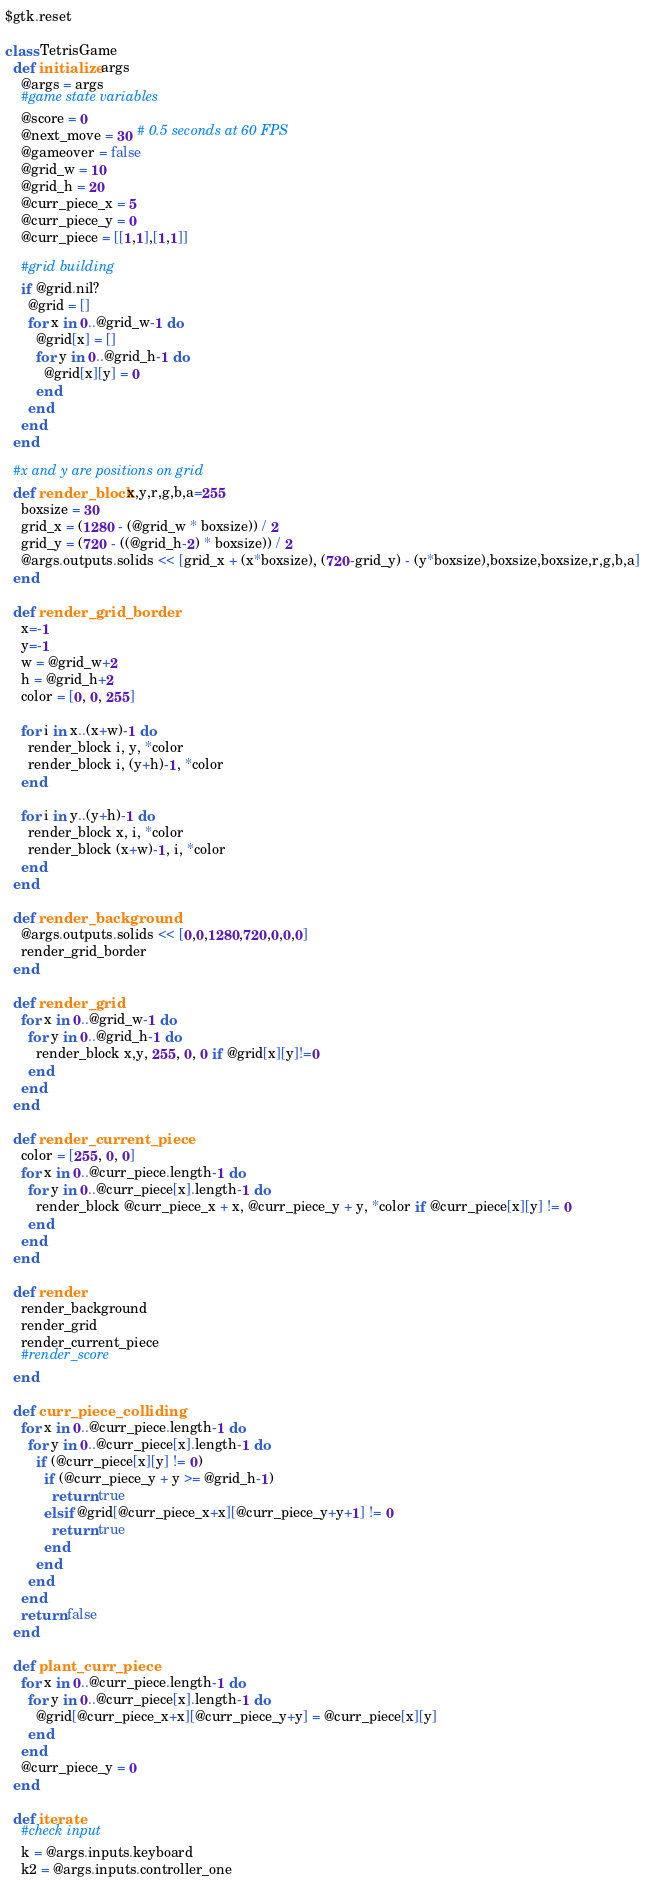Convert code to text. <code><loc_0><loc_0><loc_500><loc_500><_Ruby_>$gtk.reset

class TetrisGame
  def initialize args
    @args = args
    #game state variables
    @score = 0
    @next_move = 30 # 0.5 seconds at 60 FPS
    @gameover = false
    @grid_w = 10
    @grid_h = 20
    @curr_piece_x = 5
    @curr_piece_y = 0
    @curr_piece = [[1,1],[1,1]]

    #grid building
    if @grid.nil?
      @grid = []
      for x in 0..@grid_w-1 do
        @grid[x] = []
        for y in 0..@grid_h-1 do
          @grid[x][y] = 0
        end
      end
    end
  end

  #x and y are positions on grid
  def render_block x,y,r,g,b,a=255
    boxsize = 30
    grid_x = (1280 - (@grid_w * boxsize)) / 2
    grid_y = (720 - ((@grid_h-2) * boxsize)) / 2
    @args.outputs.solids << [grid_x + (x*boxsize), (720-grid_y) - (y*boxsize),boxsize,boxsize,r,g,b,a]
  end

  def render_grid_border
    x=-1
    y=-1
    w = @grid_w+2
    h = @grid_h+2
    color = [0, 0, 255]

    for i in x..(x+w)-1 do
      render_block i, y, *color
      render_block i, (y+h)-1, *color
    end

    for i in y..(y+h)-1 do
      render_block x, i, *color
      render_block (x+w)-1, i, *color
    end
  end

  def render_background
    @args.outputs.solids << [0,0,1280,720,0,0,0]
    render_grid_border
  end

  def render_grid
    for x in 0..@grid_w-1 do
      for y in 0..@grid_h-1 do
        render_block x,y, 255, 0, 0 if @grid[x][y]!=0
      end
    end
  end

  def render_current_piece
    color = [255, 0, 0]
    for x in 0..@curr_piece.length-1 do
      for y in 0..@curr_piece[x].length-1 do
        render_block @curr_piece_x + x, @curr_piece_y + y, *color if @curr_piece[x][y] != 0
      end
    end
  end

  def render
    render_background
    render_grid
    render_current_piece
    #render_score
  end

  def curr_piece_colliding
    for x in 0..@curr_piece.length-1 do
      for y in 0..@curr_piece[x].length-1 do
        if (@curr_piece[x][y] != 0)
          if (@curr_piece_y + y >= @grid_h-1)
            return true
          elsif @grid[@curr_piece_x+x][@curr_piece_y+y+1] != 0
            return true
          end
        end
      end
    end
    return false
  end

  def plant_curr_piece
    for x in 0..@curr_piece.length-1 do
      for y in 0..@curr_piece[x].length-1 do
        @grid[@curr_piece_x+x][@curr_piece_y+y] = @curr_piece[x][y]
      end
    end
    @curr_piece_y = 0
  end

  def iterate
    #check input
    k = @args.inputs.keyboard
    k2 = @args.inputs.controller_one</code> 